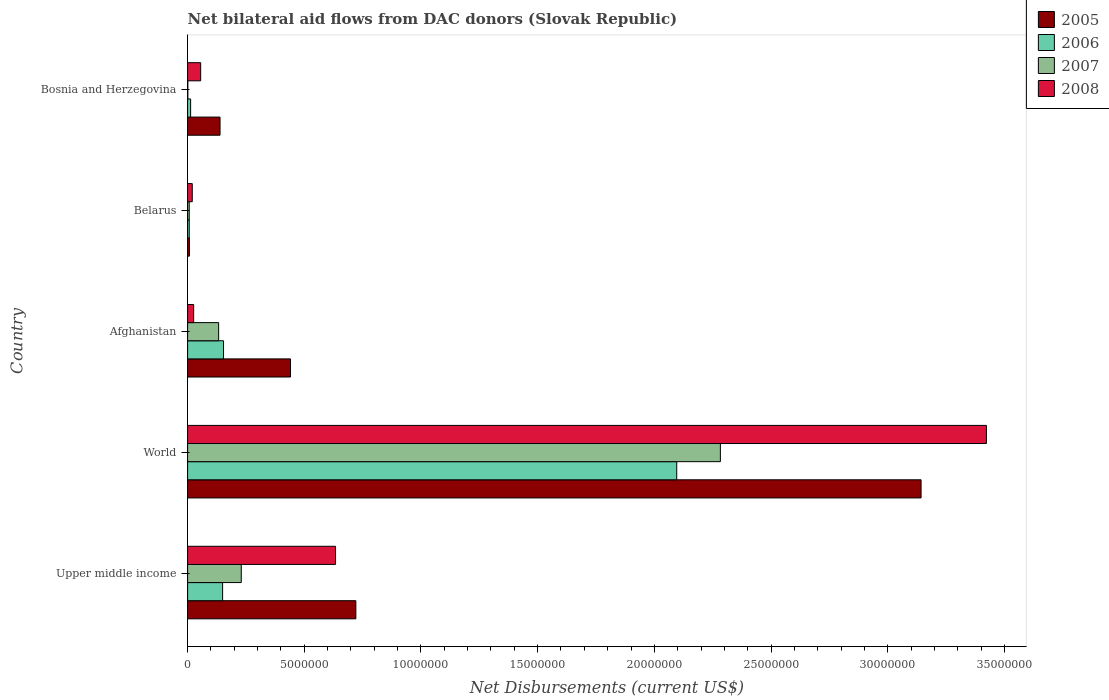How many groups of bars are there?
Keep it short and to the point. 5. Are the number of bars per tick equal to the number of legend labels?
Make the answer very short. Yes. How many bars are there on the 4th tick from the top?
Ensure brevity in your answer.  4. What is the label of the 3rd group of bars from the top?
Make the answer very short. Afghanistan. In how many cases, is the number of bars for a given country not equal to the number of legend labels?
Keep it short and to the point. 0. What is the net bilateral aid flows in 2007 in Afghanistan?
Provide a succinct answer. 1.33e+06. Across all countries, what is the maximum net bilateral aid flows in 2008?
Keep it short and to the point. 3.42e+07. Across all countries, what is the minimum net bilateral aid flows in 2008?
Make the answer very short. 2.00e+05. In which country was the net bilateral aid flows in 2007 maximum?
Offer a very short reply. World. In which country was the net bilateral aid flows in 2005 minimum?
Offer a terse response. Belarus. What is the total net bilateral aid flows in 2005 in the graph?
Offer a very short reply. 4.45e+07. What is the difference between the net bilateral aid flows in 2007 in Belarus and that in Bosnia and Herzegovina?
Ensure brevity in your answer.  6.00e+04. What is the difference between the net bilateral aid flows in 2006 in Afghanistan and the net bilateral aid flows in 2008 in Bosnia and Herzegovina?
Your answer should be very brief. 9.80e+05. What is the average net bilateral aid flows in 2007 per country?
Offer a very short reply. 5.31e+06. What is the difference between the net bilateral aid flows in 2007 and net bilateral aid flows in 2005 in Upper middle income?
Offer a terse response. -4.91e+06. In how many countries, is the net bilateral aid flows in 2008 greater than 17000000 US$?
Your answer should be very brief. 1. What is the ratio of the net bilateral aid flows in 2008 in Afghanistan to that in Upper middle income?
Keep it short and to the point. 0.04. Is the net bilateral aid flows in 2006 in Afghanistan less than that in World?
Offer a very short reply. Yes. What is the difference between the highest and the second highest net bilateral aid flows in 2008?
Provide a succinct answer. 2.79e+07. What is the difference between the highest and the lowest net bilateral aid flows in 2008?
Your answer should be compact. 3.40e+07. What does the 3rd bar from the top in Afghanistan represents?
Give a very brief answer. 2006. What does the 2nd bar from the bottom in Bosnia and Herzegovina represents?
Your answer should be compact. 2006. Are all the bars in the graph horizontal?
Provide a short and direct response. Yes. Are the values on the major ticks of X-axis written in scientific E-notation?
Keep it short and to the point. No. How are the legend labels stacked?
Your answer should be compact. Vertical. What is the title of the graph?
Your answer should be very brief. Net bilateral aid flows from DAC donors (Slovak Republic). Does "1975" appear as one of the legend labels in the graph?
Make the answer very short. No. What is the label or title of the X-axis?
Your answer should be very brief. Net Disbursements (current US$). What is the Net Disbursements (current US$) of 2005 in Upper middle income?
Offer a very short reply. 7.21e+06. What is the Net Disbursements (current US$) of 2006 in Upper middle income?
Your response must be concise. 1.50e+06. What is the Net Disbursements (current US$) in 2007 in Upper middle income?
Ensure brevity in your answer.  2.30e+06. What is the Net Disbursements (current US$) in 2008 in Upper middle income?
Provide a succinct answer. 6.34e+06. What is the Net Disbursements (current US$) of 2005 in World?
Your answer should be compact. 3.14e+07. What is the Net Disbursements (current US$) of 2006 in World?
Provide a succinct answer. 2.10e+07. What is the Net Disbursements (current US$) in 2007 in World?
Provide a succinct answer. 2.28e+07. What is the Net Disbursements (current US$) of 2008 in World?
Offer a very short reply. 3.42e+07. What is the Net Disbursements (current US$) of 2005 in Afghanistan?
Keep it short and to the point. 4.41e+06. What is the Net Disbursements (current US$) in 2006 in Afghanistan?
Offer a terse response. 1.54e+06. What is the Net Disbursements (current US$) in 2007 in Afghanistan?
Ensure brevity in your answer.  1.33e+06. What is the Net Disbursements (current US$) of 2008 in Afghanistan?
Keep it short and to the point. 2.60e+05. What is the Net Disbursements (current US$) of 2006 in Belarus?
Give a very brief answer. 7.00e+04. What is the Net Disbursements (current US$) in 2007 in Belarus?
Make the answer very short. 7.00e+04. What is the Net Disbursements (current US$) in 2008 in Belarus?
Keep it short and to the point. 2.00e+05. What is the Net Disbursements (current US$) in 2005 in Bosnia and Herzegovina?
Provide a succinct answer. 1.39e+06. What is the Net Disbursements (current US$) in 2007 in Bosnia and Herzegovina?
Your response must be concise. 10000. What is the Net Disbursements (current US$) in 2008 in Bosnia and Herzegovina?
Provide a succinct answer. 5.60e+05. Across all countries, what is the maximum Net Disbursements (current US$) of 2005?
Make the answer very short. 3.14e+07. Across all countries, what is the maximum Net Disbursements (current US$) of 2006?
Offer a terse response. 2.10e+07. Across all countries, what is the maximum Net Disbursements (current US$) in 2007?
Provide a short and direct response. 2.28e+07. Across all countries, what is the maximum Net Disbursements (current US$) in 2008?
Keep it short and to the point. 3.42e+07. Across all countries, what is the minimum Net Disbursements (current US$) in 2005?
Provide a succinct answer. 8.00e+04. Across all countries, what is the minimum Net Disbursements (current US$) of 2006?
Your response must be concise. 7.00e+04. Across all countries, what is the minimum Net Disbursements (current US$) in 2007?
Keep it short and to the point. 10000. Across all countries, what is the minimum Net Disbursements (current US$) of 2008?
Keep it short and to the point. 2.00e+05. What is the total Net Disbursements (current US$) in 2005 in the graph?
Your answer should be very brief. 4.45e+07. What is the total Net Disbursements (current US$) in 2006 in the graph?
Keep it short and to the point. 2.42e+07. What is the total Net Disbursements (current US$) in 2007 in the graph?
Your response must be concise. 2.65e+07. What is the total Net Disbursements (current US$) in 2008 in the graph?
Provide a short and direct response. 4.16e+07. What is the difference between the Net Disbursements (current US$) of 2005 in Upper middle income and that in World?
Your answer should be compact. -2.42e+07. What is the difference between the Net Disbursements (current US$) in 2006 in Upper middle income and that in World?
Provide a succinct answer. -1.95e+07. What is the difference between the Net Disbursements (current US$) in 2007 in Upper middle income and that in World?
Keep it short and to the point. -2.05e+07. What is the difference between the Net Disbursements (current US$) of 2008 in Upper middle income and that in World?
Offer a very short reply. -2.79e+07. What is the difference between the Net Disbursements (current US$) of 2005 in Upper middle income and that in Afghanistan?
Keep it short and to the point. 2.80e+06. What is the difference between the Net Disbursements (current US$) of 2006 in Upper middle income and that in Afghanistan?
Your response must be concise. -4.00e+04. What is the difference between the Net Disbursements (current US$) of 2007 in Upper middle income and that in Afghanistan?
Give a very brief answer. 9.70e+05. What is the difference between the Net Disbursements (current US$) of 2008 in Upper middle income and that in Afghanistan?
Your response must be concise. 6.08e+06. What is the difference between the Net Disbursements (current US$) in 2005 in Upper middle income and that in Belarus?
Give a very brief answer. 7.13e+06. What is the difference between the Net Disbursements (current US$) in 2006 in Upper middle income and that in Belarus?
Your answer should be very brief. 1.43e+06. What is the difference between the Net Disbursements (current US$) of 2007 in Upper middle income and that in Belarus?
Ensure brevity in your answer.  2.23e+06. What is the difference between the Net Disbursements (current US$) in 2008 in Upper middle income and that in Belarus?
Make the answer very short. 6.14e+06. What is the difference between the Net Disbursements (current US$) in 2005 in Upper middle income and that in Bosnia and Herzegovina?
Offer a terse response. 5.82e+06. What is the difference between the Net Disbursements (current US$) of 2006 in Upper middle income and that in Bosnia and Herzegovina?
Your answer should be compact. 1.37e+06. What is the difference between the Net Disbursements (current US$) in 2007 in Upper middle income and that in Bosnia and Herzegovina?
Keep it short and to the point. 2.29e+06. What is the difference between the Net Disbursements (current US$) of 2008 in Upper middle income and that in Bosnia and Herzegovina?
Your response must be concise. 5.78e+06. What is the difference between the Net Disbursements (current US$) in 2005 in World and that in Afghanistan?
Offer a terse response. 2.70e+07. What is the difference between the Net Disbursements (current US$) of 2006 in World and that in Afghanistan?
Your answer should be very brief. 1.94e+07. What is the difference between the Net Disbursements (current US$) of 2007 in World and that in Afghanistan?
Your answer should be very brief. 2.15e+07. What is the difference between the Net Disbursements (current US$) in 2008 in World and that in Afghanistan?
Offer a very short reply. 3.40e+07. What is the difference between the Net Disbursements (current US$) in 2005 in World and that in Belarus?
Ensure brevity in your answer.  3.14e+07. What is the difference between the Net Disbursements (current US$) in 2006 in World and that in Belarus?
Offer a very short reply. 2.09e+07. What is the difference between the Net Disbursements (current US$) of 2007 in World and that in Belarus?
Give a very brief answer. 2.28e+07. What is the difference between the Net Disbursements (current US$) in 2008 in World and that in Belarus?
Your response must be concise. 3.40e+07. What is the difference between the Net Disbursements (current US$) of 2005 in World and that in Bosnia and Herzegovina?
Make the answer very short. 3.00e+07. What is the difference between the Net Disbursements (current US$) of 2006 in World and that in Bosnia and Herzegovina?
Offer a terse response. 2.08e+07. What is the difference between the Net Disbursements (current US$) in 2007 in World and that in Bosnia and Herzegovina?
Your answer should be compact. 2.28e+07. What is the difference between the Net Disbursements (current US$) in 2008 in World and that in Bosnia and Herzegovina?
Offer a very short reply. 3.37e+07. What is the difference between the Net Disbursements (current US$) of 2005 in Afghanistan and that in Belarus?
Give a very brief answer. 4.33e+06. What is the difference between the Net Disbursements (current US$) in 2006 in Afghanistan and that in Belarus?
Provide a short and direct response. 1.47e+06. What is the difference between the Net Disbursements (current US$) in 2007 in Afghanistan and that in Belarus?
Provide a short and direct response. 1.26e+06. What is the difference between the Net Disbursements (current US$) in 2008 in Afghanistan and that in Belarus?
Make the answer very short. 6.00e+04. What is the difference between the Net Disbursements (current US$) of 2005 in Afghanistan and that in Bosnia and Herzegovina?
Offer a very short reply. 3.02e+06. What is the difference between the Net Disbursements (current US$) in 2006 in Afghanistan and that in Bosnia and Herzegovina?
Offer a terse response. 1.41e+06. What is the difference between the Net Disbursements (current US$) of 2007 in Afghanistan and that in Bosnia and Herzegovina?
Provide a short and direct response. 1.32e+06. What is the difference between the Net Disbursements (current US$) in 2008 in Afghanistan and that in Bosnia and Herzegovina?
Ensure brevity in your answer.  -3.00e+05. What is the difference between the Net Disbursements (current US$) in 2005 in Belarus and that in Bosnia and Herzegovina?
Keep it short and to the point. -1.31e+06. What is the difference between the Net Disbursements (current US$) of 2006 in Belarus and that in Bosnia and Herzegovina?
Provide a short and direct response. -6.00e+04. What is the difference between the Net Disbursements (current US$) of 2008 in Belarus and that in Bosnia and Herzegovina?
Your answer should be very brief. -3.60e+05. What is the difference between the Net Disbursements (current US$) of 2005 in Upper middle income and the Net Disbursements (current US$) of 2006 in World?
Provide a succinct answer. -1.38e+07. What is the difference between the Net Disbursements (current US$) in 2005 in Upper middle income and the Net Disbursements (current US$) in 2007 in World?
Offer a very short reply. -1.56e+07. What is the difference between the Net Disbursements (current US$) of 2005 in Upper middle income and the Net Disbursements (current US$) of 2008 in World?
Your answer should be compact. -2.70e+07. What is the difference between the Net Disbursements (current US$) of 2006 in Upper middle income and the Net Disbursements (current US$) of 2007 in World?
Provide a succinct answer. -2.13e+07. What is the difference between the Net Disbursements (current US$) of 2006 in Upper middle income and the Net Disbursements (current US$) of 2008 in World?
Make the answer very short. -3.27e+07. What is the difference between the Net Disbursements (current US$) in 2007 in Upper middle income and the Net Disbursements (current US$) in 2008 in World?
Provide a short and direct response. -3.19e+07. What is the difference between the Net Disbursements (current US$) in 2005 in Upper middle income and the Net Disbursements (current US$) in 2006 in Afghanistan?
Give a very brief answer. 5.67e+06. What is the difference between the Net Disbursements (current US$) of 2005 in Upper middle income and the Net Disbursements (current US$) of 2007 in Afghanistan?
Your answer should be very brief. 5.88e+06. What is the difference between the Net Disbursements (current US$) of 2005 in Upper middle income and the Net Disbursements (current US$) of 2008 in Afghanistan?
Provide a succinct answer. 6.95e+06. What is the difference between the Net Disbursements (current US$) of 2006 in Upper middle income and the Net Disbursements (current US$) of 2007 in Afghanistan?
Keep it short and to the point. 1.70e+05. What is the difference between the Net Disbursements (current US$) in 2006 in Upper middle income and the Net Disbursements (current US$) in 2008 in Afghanistan?
Offer a very short reply. 1.24e+06. What is the difference between the Net Disbursements (current US$) of 2007 in Upper middle income and the Net Disbursements (current US$) of 2008 in Afghanistan?
Provide a short and direct response. 2.04e+06. What is the difference between the Net Disbursements (current US$) in 2005 in Upper middle income and the Net Disbursements (current US$) in 2006 in Belarus?
Provide a short and direct response. 7.14e+06. What is the difference between the Net Disbursements (current US$) in 2005 in Upper middle income and the Net Disbursements (current US$) in 2007 in Belarus?
Your answer should be very brief. 7.14e+06. What is the difference between the Net Disbursements (current US$) in 2005 in Upper middle income and the Net Disbursements (current US$) in 2008 in Belarus?
Give a very brief answer. 7.01e+06. What is the difference between the Net Disbursements (current US$) in 2006 in Upper middle income and the Net Disbursements (current US$) in 2007 in Belarus?
Ensure brevity in your answer.  1.43e+06. What is the difference between the Net Disbursements (current US$) in 2006 in Upper middle income and the Net Disbursements (current US$) in 2008 in Belarus?
Give a very brief answer. 1.30e+06. What is the difference between the Net Disbursements (current US$) of 2007 in Upper middle income and the Net Disbursements (current US$) of 2008 in Belarus?
Ensure brevity in your answer.  2.10e+06. What is the difference between the Net Disbursements (current US$) of 2005 in Upper middle income and the Net Disbursements (current US$) of 2006 in Bosnia and Herzegovina?
Provide a short and direct response. 7.08e+06. What is the difference between the Net Disbursements (current US$) in 2005 in Upper middle income and the Net Disbursements (current US$) in 2007 in Bosnia and Herzegovina?
Provide a short and direct response. 7.20e+06. What is the difference between the Net Disbursements (current US$) in 2005 in Upper middle income and the Net Disbursements (current US$) in 2008 in Bosnia and Herzegovina?
Your response must be concise. 6.65e+06. What is the difference between the Net Disbursements (current US$) in 2006 in Upper middle income and the Net Disbursements (current US$) in 2007 in Bosnia and Herzegovina?
Keep it short and to the point. 1.49e+06. What is the difference between the Net Disbursements (current US$) of 2006 in Upper middle income and the Net Disbursements (current US$) of 2008 in Bosnia and Herzegovina?
Provide a short and direct response. 9.40e+05. What is the difference between the Net Disbursements (current US$) of 2007 in Upper middle income and the Net Disbursements (current US$) of 2008 in Bosnia and Herzegovina?
Give a very brief answer. 1.74e+06. What is the difference between the Net Disbursements (current US$) of 2005 in World and the Net Disbursements (current US$) of 2006 in Afghanistan?
Keep it short and to the point. 2.99e+07. What is the difference between the Net Disbursements (current US$) in 2005 in World and the Net Disbursements (current US$) in 2007 in Afghanistan?
Provide a succinct answer. 3.01e+07. What is the difference between the Net Disbursements (current US$) in 2005 in World and the Net Disbursements (current US$) in 2008 in Afghanistan?
Provide a short and direct response. 3.12e+07. What is the difference between the Net Disbursements (current US$) in 2006 in World and the Net Disbursements (current US$) in 2007 in Afghanistan?
Your response must be concise. 1.96e+07. What is the difference between the Net Disbursements (current US$) in 2006 in World and the Net Disbursements (current US$) in 2008 in Afghanistan?
Provide a short and direct response. 2.07e+07. What is the difference between the Net Disbursements (current US$) in 2007 in World and the Net Disbursements (current US$) in 2008 in Afghanistan?
Give a very brief answer. 2.26e+07. What is the difference between the Net Disbursements (current US$) in 2005 in World and the Net Disbursements (current US$) in 2006 in Belarus?
Give a very brief answer. 3.14e+07. What is the difference between the Net Disbursements (current US$) in 2005 in World and the Net Disbursements (current US$) in 2007 in Belarus?
Offer a very short reply. 3.14e+07. What is the difference between the Net Disbursements (current US$) of 2005 in World and the Net Disbursements (current US$) of 2008 in Belarus?
Your response must be concise. 3.12e+07. What is the difference between the Net Disbursements (current US$) of 2006 in World and the Net Disbursements (current US$) of 2007 in Belarus?
Keep it short and to the point. 2.09e+07. What is the difference between the Net Disbursements (current US$) in 2006 in World and the Net Disbursements (current US$) in 2008 in Belarus?
Make the answer very short. 2.08e+07. What is the difference between the Net Disbursements (current US$) in 2007 in World and the Net Disbursements (current US$) in 2008 in Belarus?
Ensure brevity in your answer.  2.26e+07. What is the difference between the Net Disbursements (current US$) in 2005 in World and the Net Disbursements (current US$) in 2006 in Bosnia and Herzegovina?
Offer a terse response. 3.13e+07. What is the difference between the Net Disbursements (current US$) of 2005 in World and the Net Disbursements (current US$) of 2007 in Bosnia and Herzegovina?
Your answer should be very brief. 3.14e+07. What is the difference between the Net Disbursements (current US$) in 2005 in World and the Net Disbursements (current US$) in 2008 in Bosnia and Herzegovina?
Offer a very short reply. 3.09e+07. What is the difference between the Net Disbursements (current US$) in 2006 in World and the Net Disbursements (current US$) in 2007 in Bosnia and Herzegovina?
Your answer should be compact. 2.10e+07. What is the difference between the Net Disbursements (current US$) in 2006 in World and the Net Disbursements (current US$) in 2008 in Bosnia and Herzegovina?
Provide a succinct answer. 2.04e+07. What is the difference between the Net Disbursements (current US$) of 2007 in World and the Net Disbursements (current US$) of 2008 in Bosnia and Herzegovina?
Provide a succinct answer. 2.23e+07. What is the difference between the Net Disbursements (current US$) of 2005 in Afghanistan and the Net Disbursements (current US$) of 2006 in Belarus?
Give a very brief answer. 4.34e+06. What is the difference between the Net Disbursements (current US$) in 2005 in Afghanistan and the Net Disbursements (current US$) in 2007 in Belarus?
Ensure brevity in your answer.  4.34e+06. What is the difference between the Net Disbursements (current US$) in 2005 in Afghanistan and the Net Disbursements (current US$) in 2008 in Belarus?
Keep it short and to the point. 4.21e+06. What is the difference between the Net Disbursements (current US$) of 2006 in Afghanistan and the Net Disbursements (current US$) of 2007 in Belarus?
Offer a very short reply. 1.47e+06. What is the difference between the Net Disbursements (current US$) of 2006 in Afghanistan and the Net Disbursements (current US$) of 2008 in Belarus?
Make the answer very short. 1.34e+06. What is the difference between the Net Disbursements (current US$) in 2007 in Afghanistan and the Net Disbursements (current US$) in 2008 in Belarus?
Your answer should be compact. 1.13e+06. What is the difference between the Net Disbursements (current US$) in 2005 in Afghanistan and the Net Disbursements (current US$) in 2006 in Bosnia and Herzegovina?
Your response must be concise. 4.28e+06. What is the difference between the Net Disbursements (current US$) in 2005 in Afghanistan and the Net Disbursements (current US$) in 2007 in Bosnia and Herzegovina?
Your answer should be very brief. 4.40e+06. What is the difference between the Net Disbursements (current US$) of 2005 in Afghanistan and the Net Disbursements (current US$) of 2008 in Bosnia and Herzegovina?
Your response must be concise. 3.85e+06. What is the difference between the Net Disbursements (current US$) in 2006 in Afghanistan and the Net Disbursements (current US$) in 2007 in Bosnia and Herzegovina?
Make the answer very short. 1.53e+06. What is the difference between the Net Disbursements (current US$) of 2006 in Afghanistan and the Net Disbursements (current US$) of 2008 in Bosnia and Herzegovina?
Offer a terse response. 9.80e+05. What is the difference between the Net Disbursements (current US$) in 2007 in Afghanistan and the Net Disbursements (current US$) in 2008 in Bosnia and Herzegovina?
Your answer should be very brief. 7.70e+05. What is the difference between the Net Disbursements (current US$) of 2005 in Belarus and the Net Disbursements (current US$) of 2006 in Bosnia and Herzegovina?
Provide a short and direct response. -5.00e+04. What is the difference between the Net Disbursements (current US$) in 2005 in Belarus and the Net Disbursements (current US$) in 2008 in Bosnia and Herzegovina?
Your answer should be compact. -4.80e+05. What is the difference between the Net Disbursements (current US$) of 2006 in Belarus and the Net Disbursements (current US$) of 2008 in Bosnia and Herzegovina?
Provide a short and direct response. -4.90e+05. What is the difference between the Net Disbursements (current US$) of 2007 in Belarus and the Net Disbursements (current US$) of 2008 in Bosnia and Herzegovina?
Give a very brief answer. -4.90e+05. What is the average Net Disbursements (current US$) of 2005 per country?
Make the answer very short. 8.90e+06. What is the average Net Disbursements (current US$) of 2006 per country?
Ensure brevity in your answer.  4.84e+06. What is the average Net Disbursements (current US$) in 2007 per country?
Your response must be concise. 5.31e+06. What is the average Net Disbursements (current US$) in 2008 per country?
Offer a very short reply. 8.32e+06. What is the difference between the Net Disbursements (current US$) in 2005 and Net Disbursements (current US$) in 2006 in Upper middle income?
Your answer should be compact. 5.71e+06. What is the difference between the Net Disbursements (current US$) of 2005 and Net Disbursements (current US$) of 2007 in Upper middle income?
Your response must be concise. 4.91e+06. What is the difference between the Net Disbursements (current US$) in 2005 and Net Disbursements (current US$) in 2008 in Upper middle income?
Keep it short and to the point. 8.70e+05. What is the difference between the Net Disbursements (current US$) of 2006 and Net Disbursements (current US$) of 2007 in Upper middle income?
Your answer should be compact. -8.00e+05. What is the difference between the Net Disbursements (current US$) in 2006 and Net Disbursements (current US$) in 2008 in Upper middle income?
Make the answer very short. -4.84e+06. What is the difference between the Net Disbursements (current US$) in 2007 and Net Disbursements (current US$) in 2008 in Upper middle income?
Provide a succinct answer. -4.04e+06. What is the difference between the Net Disbursements (current US$) in 2005 and Net Disbursements (current US$) in 2006 in World?
Make the answer very short. 1.05e+07. What is the difference between the Net Disbursements (current US$) in 2005 and Net Disbursements (current US$) in 2007 in World?
Your answer should be very brief. 8.60e+06. What is the difference between the Net Disbursements (current US$) in 2005 and Net Disbursements (current US$) in 2008 in World?
Your answer should be very brief. -2.80e+06. What is the difference between the Net Disbursements (current US$) in 2006 and Net Disbursements (current US$) in 2007 in World?
Provide a succinct answer. -1.87e+06. What is the difference between the Net Disbursements (current US$) in 2006 and Net Disbursements (current US$) in 2008 in World?
Provide a succinct answer. -1.33e+07. What is the difference between the Net Disbursements (current US$) of 2007 and Net Disbursements (current US$) of 2008 in World?
Provide a short and direct response. -1.14e+07. What is the difference between the Net Disbursements (current US$) of 2005 and Net Disbursements (current US$) of 2006 in Afghanistan?
Your answer should be compact. 2.87e+06. What is the difference between the Net Disbursements (current US$) in 2005 and Net Disbursements (current US$) in 2007 in Afghanistan?
Offer a very short reply. 3.08e+06. What is the difference between the Net Disbursements (current US$) in 2005 and Net Disbursements (current US$) in 2008 in Afghanistan?
Provide a succinct answer. 4.15e+06. What is the difference between the Net Disbursements (current US$) of 2006 and Net Disbursements (current US$) of 2007 in Afghanistan?
Ensure brevity in your answer.  2.10e+05. What is the difference between the Net Disbursements (current US$) of 2006 and Net Disbursements (current US$) of 2008 in Afghanistan?
Give a very brief answer. 1.28e+06. What is the difference between the Net Disbursements (current US$) of 2007 and Net Disbursements (current US$) of 2008 in Afghanistan?
Make the answer very short. 1.07e+06. What is the difference between the Net Disbursements (current US$) of 2005 and Net Disbursements (current US$) of 2007 in Belarus?
Provide a short and direct response. 10000. What is the difference between the Net Disbursements (current US$) in 2005 and Net Disbursements (current US$) in 2008 in Belarus?
Ensure brevity in your answer.  -1.20e+05. What is the difference between the Net Disbursements (current US$) of 2005 and Net Disbursements (current US$) of 2006 in Bosnia and Herzegovina?
Offer a very short reply. 1.26e+06. What is the difference between the Net Disbursements (current US$) in 2005 and Net Disbursements (current US$) in 2007 in Bosnia and Herzegovina?
Give a very brief answer. 1.38e+06. What is the difference between the Net Disbursements (current US$) in 2005 and Net Disbursements (current US$) in 2008 in Bosnia and Herzegovina?
Ensure brevity in your answer.  8.30e+05. What is the difference between the Net Disbursements (current US$) in 2006 and Net Disbursements (current US$) in 2008 in Bosnia and Herzegovina?
Give a very brief answer. -4.30e+05. What is the difference between the Net Disbursements (current US$) of 2007 and Net Disbursements (current US$) of 2008 in Bosnia and Herzegovina?
Make the answer very short. -5.50e+05. What is the ratio of the Net Disbursements (current US$) of 2005 in Upper middle income to that in World?
Provide a succinct answer. 0.23. What is the ratio of the Net Disbursements (current US$) in 2006 in Upper middle income to that in World?
Keep it short and to the point. 0.07. What is the ratio of the Net Disbursements (current US$) in 2007 in Upper middle income to that in World?
Your answer should be very brief. 0.1. What is the ratio of the Net Disbursements (current US$) in 2008 in Upper middle income to that in World?
Provide a short and direct response. 0.19. What is the ratio of the Net Disbursements (current US$) in 2005 in Upper middle income to that in Afghanistan?
Ensure brevity in your answer.  1.63. What is the ratio of the Net Disbursements (current US$) of 2007 in Upper middle income to that in Afghanistan?
Your answer should be very brief. 1.73. What is the ratio of the Net Disbursements (current US$) of 2008 in Upper middle income to that in Afghanistan?
Ensure brevity in your answer.  24.38. What is the ratio of the Net Disbursements (current US$) of 2005 in Upper middle income to that in Belarus?
Keep it short and to the point. 90.12. What is the ratio of the Net Disbursements (current US$) of 2006 in Upper middle income to that in Belarus?
Provide a short and direct response. 21.43. What is the ratio of the Net Disbursements (current US$) in 2007 in Upper middle income to that in Belarus?
Provide a short and direct response. 32.86. What is the ratio of the Net Disbursements (current US$) in 2008 in Upper middle income to that in Belarus?
Give a very brief answer. 31.7. What is the ratio of the Net Disbursements (current US$) in 2005 in Upper middle income to that in Bosnia and Herzegovina?
Offer a very short reply. 5.19. What is the ratio of the Net Disbursements (current US$) of 2006 in Upper middle income to that in Bosnia and Herzegovina?
Offer a very short reply. 11.54. What is the ratio of the Net Disbursements (current US$) in 2007 in Upper middle income to that in Bosnia and Herzegovina?
Keep it short and to the point. 230. What is the ratio of the Net Disbursements (current US$) in 2008 in Upper middle income to that in Bosnia and Herzegovina?
Make the answer very short. 11.32. What is the ratio of the Net Disbursements (current US$) of 2005 in World to that in Afghanistan?
Make the answer very short. 7.13. What is the ratio of the Net Disbursements (current US$) in 2006 in World to that in Afghanistan?
Offer a terse response. 13.61. What is the ratio of the Net Disbursements (current US$) of 2007 in World to that in Afghanistan?
Your answer should be very brief. 17.17. What is the ratio of the Net Disbursements (current US$) of 2008 in World to that in Afghanistan?
Offer a very short reply. 131.65. What is the ratio of the Net Disbursements (current US$) of 2005 in World to that in Belarus?
Make the answer very short. 392.88. What is the ratio of the Net Disbursements (current US$) of 2006 in World to that in Belarus?
Your answer should be very brief. 299.43. What is the ratio of the Net Disbursements (current US$) of 2007 in World to that in Belarus?
Your answer should be compact. 326.14. What is the ratio of the Net Disbursements (current US$) in 2008 in World to that in Belarus?
Make the answer very short. 171.15. What is the ratio of the Net Disbursements (current US$) of 2005 in World to that in Bosnia and Herzegovina?
Your answer should be very brief. 22.61. What is the ratio of the Net Disbursements (current US$) of 2006 in World to that in Bosnia and Herzegovina?
Provide a succinct answer. 161.23. What is the ratio of the Net Disbursements (current US$) of 2007 in World to that in Bosnia and Herzegovina?
Make the answer very short. 2283. What is the ratio of the Net Disbursements (current US$) in 2008 in World to that in Bosnia and Herzegovina?
Offer a very short reply. 61.12. What is the ratio of the Net Disbursements (current US$) of 2005 in Afghanistan to that in Belarus?
Provide a short and direct response. 55.12. What is the ratio of the Net Disbursements (current US$) of 2008 in Afghanistan to that in Belarus?
Make the answer very short. 1.3. What is the ratio of the Net Disbursements (current US$) of 2005 in Afghanistan to that in Bosnia and Herzegovina?
Provide a succinct answer. 3.17. What is the ratio of the Net Disbursements (current US$) in 2006 in Afghanistan to that in Bosnia and Herzegovina?
Your response must be concise. 11.85. What is the ratio of the Net Disbursements (current US$) of 2007 in Afghanistan to that in Bosnia and Herzegovina?
Give a very brief answer. 133. What is the ratio of the Net Disbursements (current US$) of 2008 in Afghanistan to that in Bosnia and Herzegovina?
Ensure brevity in your answer.  0.46. What is the ratio of the Net Disbursements (current US$) in 2005 in Belarus to that in Bosnia and Herzegovina?
Provide a succinct answer. 0.06. What is the ratio of the Net Disbursements (current US$) of 2006 in Belarus to that in Bosnia and Herzegovina?
Your answer should be very brief. 0.54. What is the ratio of the Net Disbursements (current US$) of 2008 in Belarus to that in Bosnia and Herzegovina?
Make the answer very short. 0.36. What is the difference between the highest and the second highest Net Disbursements (current US$) of 2005?
Offer a terse response. 2.42e+07. What is the difference between the highest and the second highest Net Disbursements (current US$) of 2006?
Keep it short and to the point. 1.94e+07. What is the difference between the highest and the second highest Net Disbursements (current US$) of 2007?
Make the answer very short. 2.05e+07. What is the difference between the highest and the second highest Net Disbursements (current US$) of 2008?
Provide a succinct answer. 2.79e+07. What is the difference between the highest and the lowest Net Disbursements (current US$) of 2005?
Provide a succinct answer. 3.14e+07. What is the difference between the highest and the lowest Net Disbursements (current US$) in 2006?
Make the answer very short. 2.09e+07. What is the difference between the highest and the lowest Net Disbursements (current US$) of 2007?
Your answer should be compact. 2.28e+07. What is the difference between the highest and the lowest Net Disbursements (current US$) in 2008?
Provide a succinct answer. 3.40e+07. 